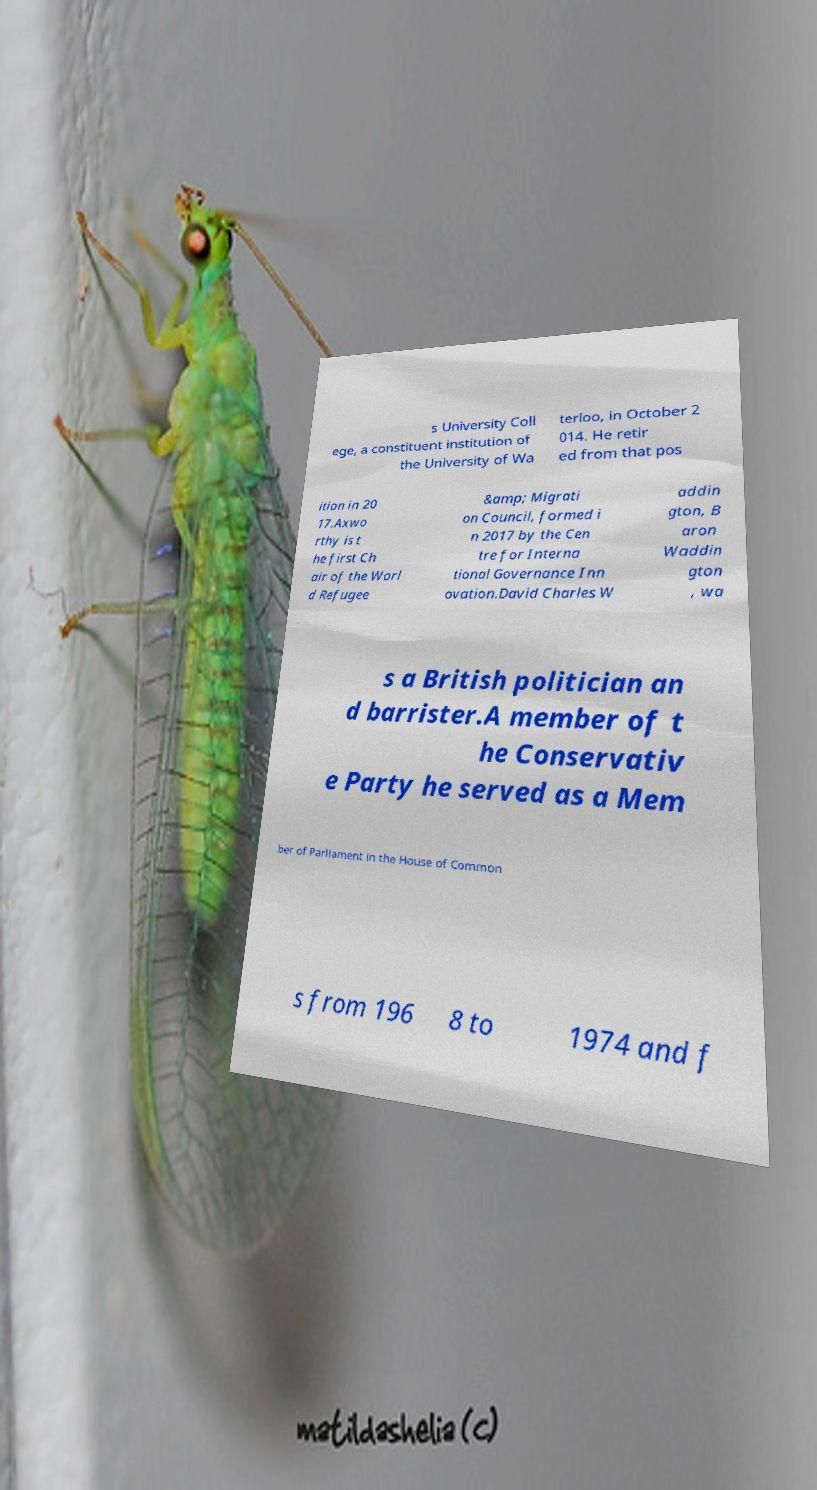Could you assist in decoding the text presented in this image and type it out clearly? s University Coll ege, a constituent institution of the University of Wa terloo, in October 2 014. He retir ed from that pos ition in 20 17.Axwo rthy is t he first Ch air of the Worl d Refugee &amp; Migrati on Council, formed i n 2017 by the Cen tre for Interna tional Governance Inn ovation.David Charles W addin gton, B aron Waddin gton , wa s a British politician an d barrister.A member of t he Conservativ e Party he served as a Mem ber of Parliament in the House of Common s from 196 8 to 1974 and f 